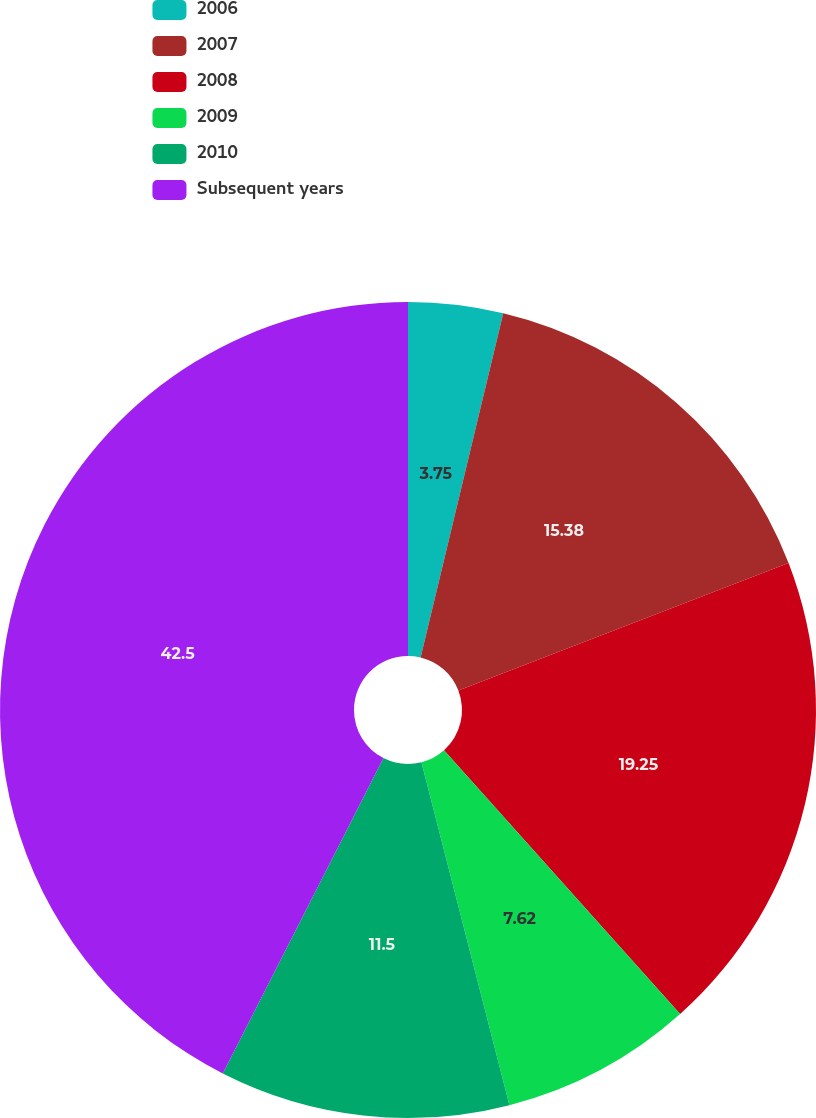Convert chart. <chart><loc_0><loc_0><loc_500><loc_500><pie_chart><fcel>2006<fcel>2007<fcel>2008<fcel>2009<fcel>2010<fcel>Subsequent years<nl><fcel>3.75%<fcel>15.38%<fcel>19.25%<fcel>7.62%<fcel>11.5%<fcel>42.5%<nl></chart> 